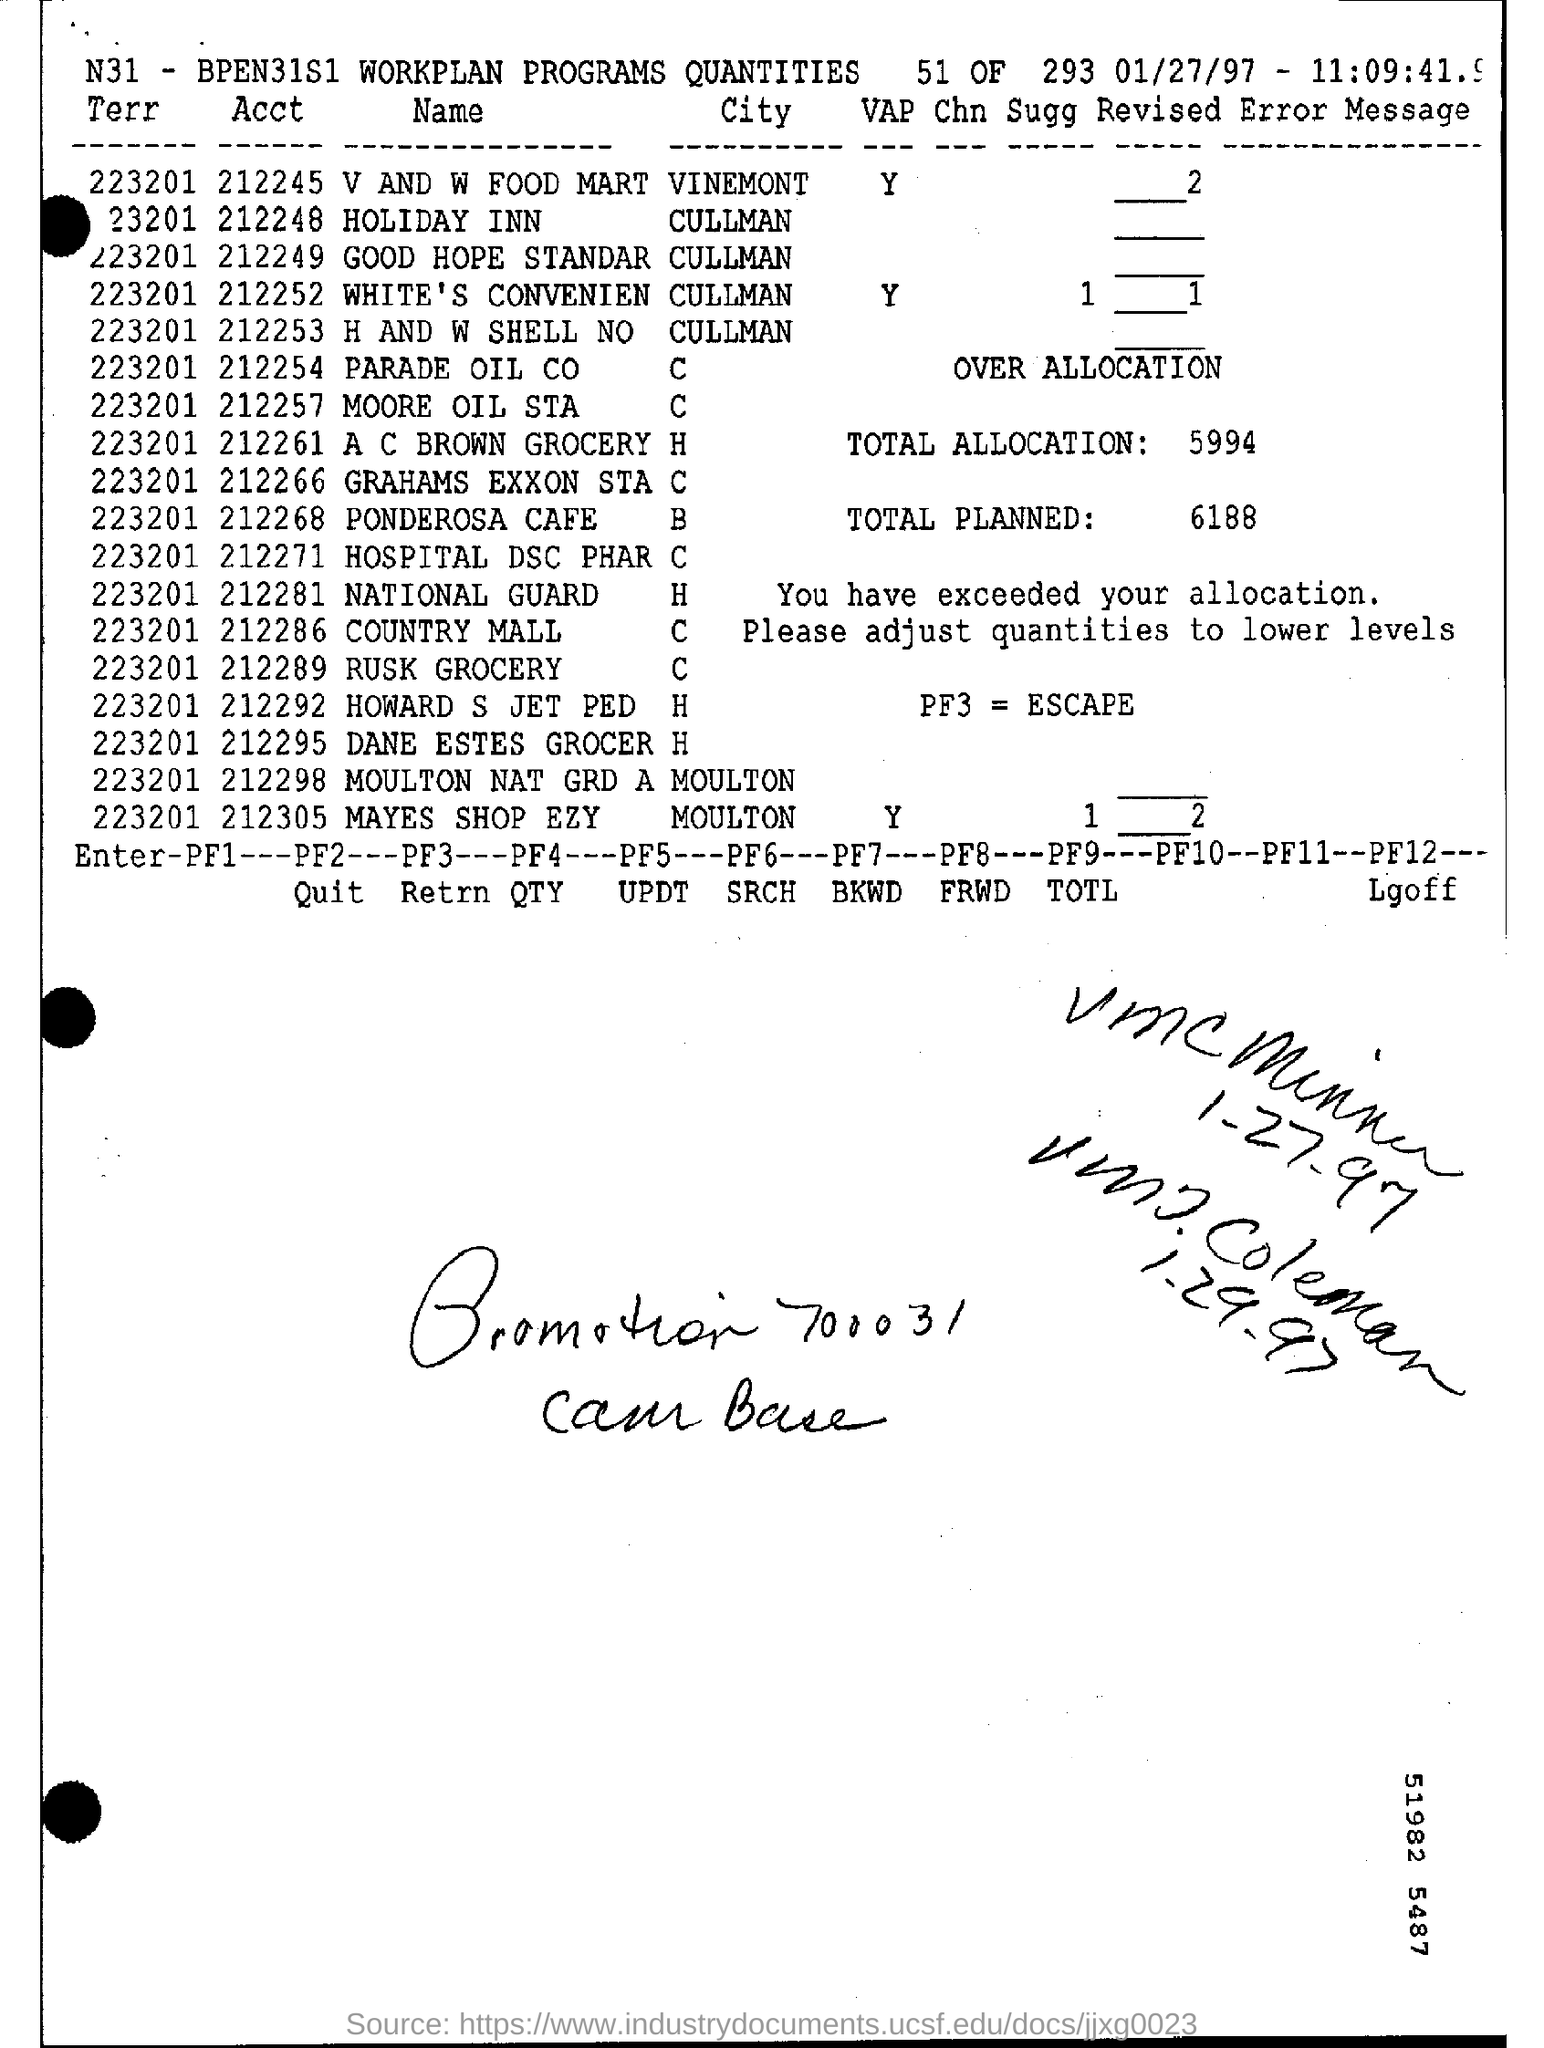What is pf3 =?
Keep it short and to the point. Escape. How much is the total allocation ?
Your answer should be very brief. 5994. What is the total planned?
Provide a short and direct response. 6188. In which city is v and w food mart located?
Make the answer very short. Vinemont. Mention date at top right corner of the page ?
Ensure brevity in your answer.  01/27/97. 